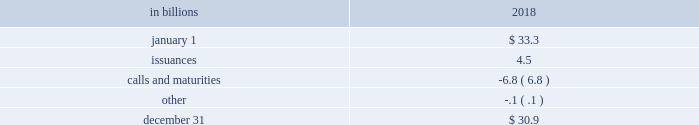The pnc financial services group , inc .
2013 form 10-k 65 liquidity and capital management liquidity risk has two fundamental components .
The first is potential loss assuming we were unable to meet our funding requirements at a reasonable cost .
The second is the potential inability to operate our businesses because adequate contingent liquidity is not available .
We manage liquidity risk at the consolidated company level ( bank , parent company and nonbank subsidiaries combined ) to help ensure that we can obtain cost-effective funding to meet current and future obligations under both normal 201cbusiness as usual 201d and stressful circumstances , and to help ensure that we maintain an appropriate level of contingent liquidity .
Management monitors liquidity through a series of early warning indicators that may indicate a potential market , or pnc-specific , liquidity stress event .
In addition , management performs a set of liquidity stress tests over multiple time horizons with varying levels of severity and maintains a contingency funding plan to address a potential liquidity stress event .
In the most severe liquidity stress simulation , we assume that our liquidity position is under pressure , while the market in general is under systemic pressure .
The simulation considers , among other things , the impact of restricted access to both secured and unsecured external sources of funding , accelerated run-off of customer deposits , valuation pressure on assets and heavy demand to fund committed obligations .
Parent company liquidity guidelines are designed to help ensure that sufficient liquidity is available to meet our parent company obligations over the succeeding 24-month period .
Liquidity-related risk limits are established within our enterprise liquidity management policy and supporting policies .
Management committees , including the asset and liability committee , and the board of directors and its risk committee regularly review compliance with key established limits .
In addition to these liquidity monitoring measures and tools described above , we also monitor our liquidity by reference to the liquidity coverage ratio ( lcr ) which is further described in the supervision and regulation section in item 1 of this report .
Pnc and pnc bank calculate the lcr on a daily basis and as of december 31 , 2018 , the lcr for pnc and pnc bank exceeded the fully phased-in requirement of 100% ( 100 % ) .
We provide additional information regarding regulatory liquidity requirements and their potential impact on us in the supervision and regulation section of item 1 business and item 1a risk factors of this report .
Sources of liquidity our largest source of liquidity on a consolidated basis is the customer deposit base generated by our banking businesses .
These deposits provide relatively stable and low-cost funding .
Total deposits increased to $ 267.8 billion at december 31 , 2018 from $ 265.1 billion at december 31 , 2017 driven by growth in interest-bearing deposits partially offset by a decrease in noninterest-bearing deposits .
See the funding sources section of the consolidated balance sheet review in this report for additional information related to our deposits .
Additionally , certain assets determined by us to be liquid as well as unused borrowing capacity from a number of sources are also available to manage our liquidity position .
At december 31 , 2018 , our liquid assets consisted of short-term investments ( federal funds sold , resale agreements , trading securities and interest-earning deposits with banks ) totaling $ 22.1 billion and securities available for sale totaling $ 63.4 billion .
The level of liquid assets fluctuates over time based on many factors , including market conditions , loan and deposit growth and balance sheet management activities .
Our liquid assets included $ 2.7 billion of securities available for sale and trading securities pledged as collateral to secure public and trust deposits , repurchase agreements and for other purposes .
In addition , $ 4.9 billion of securities held to maturity were also pledged as collateral for these purposes .
We also obtain liquidity through various forms of funding , including long-term debt ( senior notes , subordinated debt and fhlb borrowings ) and short-term borrowings ( securities sold under repurchase agreements , commercial paper and other short-term borrowings ) .
See note 10 borrowed funds and the funding sources section of the consolidated balance sheet review in this report for additional information related to our borrowings .
Total senior and subordinated debt , on a consolidated basis , decreased due to the following activity : table 24 : senior and subordinated debt .

Were total deposits at december 31 , 2018 greater than total senior and subordinated debt? 
Computations: (267.8 > 30.9)
Answer: yes. The pnc financial services group , inc .
2013 form 10-k 65 liquidity and capital management liquidity risk has two fundamental components .
The first is potential loss assuming we were unable to meet our funding requirements at a reasonable cost .
The second is the potential inability to operate our businesses because adequate contingent liquidity is not available .
We manage liquidity risk at the consolidated company level ( bank , parent company and nonbank subsidiaries combined ) to help ensure that we can obtain cost-effective funding to meet current and future obligations under both normal 201cbusiness as usual 201d and stressful circumstances , and to help ensure that we maintain an appropriate level of contingent liquidity .
Management monitors liquidity through a series of early warning indicators that may indicate a potential market , or pnc-specific , liquidity stress event .
In addition , management performs a set of liquidity stress tests over multiple time horizons with varying levels of severity and maintains a contingency funding plan to address a potential liquidity stress event .
In the most severe liquidity stress simulation , we assume that our liquidity position is under pressure , while the market in general is under systemic pressure .
The simulation considers , among other things , the impact of restricted access to both secured and unsecured external sources of funding , accelerated run-off of customer deposits , valuation pressure on assets and heavy demand to fund committed obligations .
Parent company liquidity guidelines are designed to help ensure that sufficient liquidity is available to meet our parent company obligations over the succeeding 24-month period .
Liquidity-related risk limits are established within our enterprise liquidity management policy and supporting policies .
Management committees , including the asset and liability committee , and the board of directors and its risk committee regularly review compliance with key established limits .
In addition to these liquidity monitoring measures and tools described above , we also monitor our liquidity by reference to the liquidity coverage ratio ( lcr ) which is further described in the supervision and regulation section in item 1 of this report .
Pnc and pnc bank calculate the lcr on a daily basis and as of december 31 , 2018 , the lcr for pnc and pnc bank exceeded the fully phased-in requirement of 100% ( 100 % ) .
We provide additional information regarding regulatory liquidity requirements and their potential impact on us in the supervision and regulation section of item 1 business and item 1a risk factors of this report .
Sources of liquidity our largest source of liquidity on a consolidated basis is the customer deposit base generated by our banking businesses .
These deposits provide relatively stable and low-cost funding .
Total deposits increased to $ 267.8 billion at december 31 , 2018 from $ 265.1 billion at december 31 , 2017 driven by growth in interest-bearing deposits partially offset by a decrease in noninterest-bearing deposits .
See the funding sources section of the consolidated balance sheet review in this report for additional information related to our deposits .
Additionally , certain assets determined by us to be liquid as well as unused borrowing capacity from a number of sources are also available to manage our liquidity position .
At december 31 , 2018 , our liquid assets consisted of short-term investments ( federal funds sold , resale agreements , trading securities and interest-earning deposits with banks ) totaling $ 22.1 billion and securities available for sale totaling $ 63.4 billion .
The level of liquid assets fluctuates over time based on many factors , including market conditions , loan and deposit growth and balance sheet management activities .
Our liquid assets included $ 2.7 billion of securities available for sale and trading securities pledged as collateral to secure public and trust deposits , repurchase agreements and for other purposes .
In addition , $ 4.9 billion of securities held to maturity were also pledged as collateral for these purposes .
We also obtain liquidity through various forms of funding , including long-term debt ( senior notes , subordinated debt and fhlb borrowings ) and short-term borrowings ( securities sold under repurchase agreements , commercial paper and other short-term borrowings ) .
See note 10 borrowed funds and the funding sources section of the consolidated balance sheet review in this report for additional information related to our borrowings .
Total senior and subordinated debt , on a consolidated basis , decreased due to the following activity : table 24 : senior and subordinated debt .

What was the total percentage increase in total deposits from dec 31 , 2017 to dec 31 , 2018? 
Computations: ((267.8 - 265.1) / 265.1)
Answer: 0.01018. 